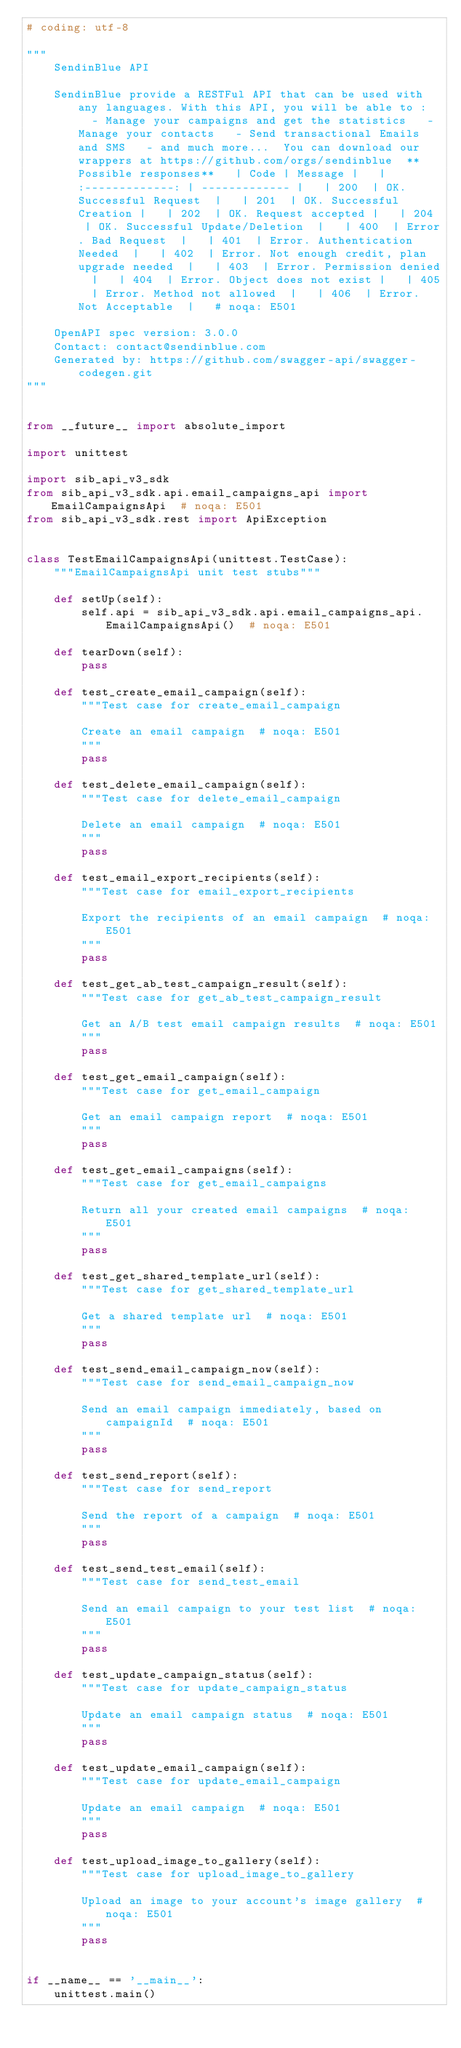<code> <loc_0><loc_0><loc_500><loc_500><_Python_># coding: utf-8

"""
    SendinBlue API

    SendinBlue provide a RESTFul API that can be used with any languages. With this API, you will be able to :   - Manage your campaigns and get the statistics   - Manage your contacts   - Send transactional Emails and SMS   - and much more...  You can download our wrappers at https://github.com/orgs/sendinblue  **Possible responses**   | Code | Message |   | :-------------: | ------------- |   | 200  | OK. Successful Request  |   | 201  | OK. Successful Creation |   | 202  | OK. Request accepted |   | 204  | OK. Successful Update/Deletion  |   | 400  | Error. Bad Request  |   | 401  | Error. Authentication Needed  |   | 402  | Error. Not enough credit, plan upgrade needed  |   | 403  | Error. Permission denied  |   | 404  | Error. Object does not exist |   | 405  | Error. Method not allowed  |   | 406  | Error. Not Acceptable  |   # noqa: E501

    OpenAPI spec version: 3.0.0
    Contact: contact@sendinblue.com
    Generated by: https://github.com/swagger-api/swagger-codegen.git
"""


from __future__ import absolute_import

import unittest

import sib_api_v3_sdk
from sib_api_v3_sdk.api.email_campaigns_api import EmailCampaignsApi  # noqa: E501
from sib_api_v3_sdk.rest import ApiException


class TestEmailCampaignsApi(unittest.TestCase):
    """EmailCampaignsApi unit test stubs"""

    def setUp(self):
        self.api = sib_api_v3_sdk.api.email_campaigns_api.EmailCampaignsApi()  # noqa: E501

    def tearDown(self):
        pass

    def test_create_email_campaign(self):
        """Test case for create_email_campaign

        Create an email campaign  # noqa: E501
        """
        pass

    def test_delete_email_campaign(self):
        """Test case for delete_email_campaign

        Delete an email campaign  # noqa: E501
        """
        pass

    def test_email_export_recipients(self):
        """Test case for email_export_recipients

        Export the recipients of an email campaign  # noqa: E501
        """
        pass

    def test_get_ab_test_campaign_result(self):
        """Test case for get_ab_test_campaign_result

        Get an A/B test email campaign results  # noqa: E501
        """
        pass

    def test_get_email_campaign(self):
        """Test case for get_email_campaign

        Get an email campaign report  # noqa: E501
        """
        pass

    def test_get_email_campaigns(self):
        """Test case for get_email_campaigns

        Return all your created email campaigns  # noqa: E501
        """
        pass

    def test_get_shared_template_url(self):
        """Test case for get_shared_template_url

        Get a shared template url  # noqa: E501
        """
        pass

    def test_send_email_campaign_now(self):
        """Test case for send_email_campaign_now

        Send an email campaign immediately, based on campaignId  # noqa: E501
        """
        pass

    def test_send_report(self):
        """Test case for send_report

        Send the report of a campaign  # noqa: E501
        """
        pass

    def test_send_test_email(self):
        """Test case for send_test_email

        Send an email campaign to your test list  # noqa: E501
        """
        pass

    def test_update_campaign_status(self):
        """Test case for update_campaign_status

        Update an email campaign status  # noqa: E501
        """
        pass

    def test_update_email_campaign(self):
        """Test case for update_email_campaign

        Update an email campaign  # noqa: E501
        """
        pass

    def test_upload_image_to_gallery(self):
        """Test case for upload_image_to_gallery

        Upload an image to your account's image gallery  # noqa: E501
        """
        pass


if __name__ == '__main__':
    unittest.main()
</code> 